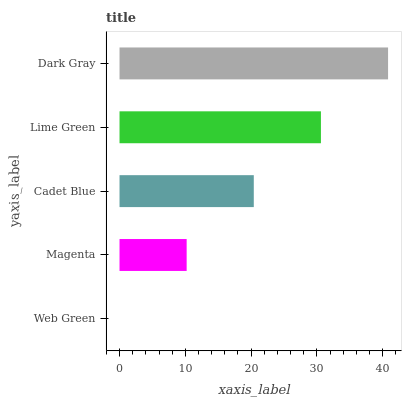Is Web Green the minimum?
Answer yes or no. Yes. Is Dark Gray the maximum?
Answer yes or no. Yes. Is Magenta the minimum?
Answer yes or no. No. Is Magenta the maximum?
Answer yes or no. No. Is Magenta greater than Web Green?
Answer yes or no. Yes. Is Web Green less than Magenta?
Answer yes or no. Yes. Is Web Green greater than Magenta?
Answer yes or no. No. Is Magenta less than Web Green?
Answer yes or no. No. Is Cadet Blue the high median?
Answer yes or no. Yes. Is Cadet Blue the low median?
Answer yes or no. Yes. Is Web Green the high median?
Answer yes or no. No. Is Magenta the low median?
Answer yes or no. No. 